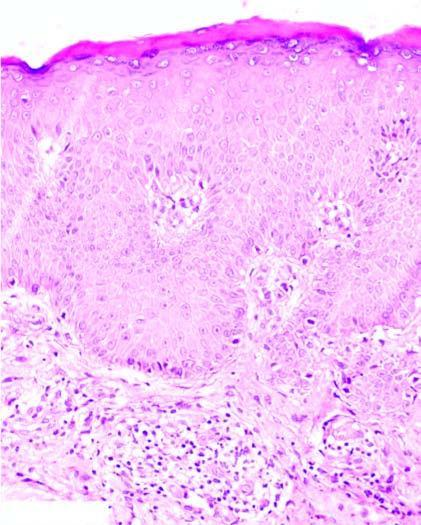does an intimal show hyperkeratosis, acathosis and broadened papillae and spongiosis of the epidermal layers?
Answer the question using a single word or phrase. No 